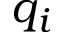<formula> <loc_0><loc_0><loc_500><loc_500>q _ { i }</formula> 